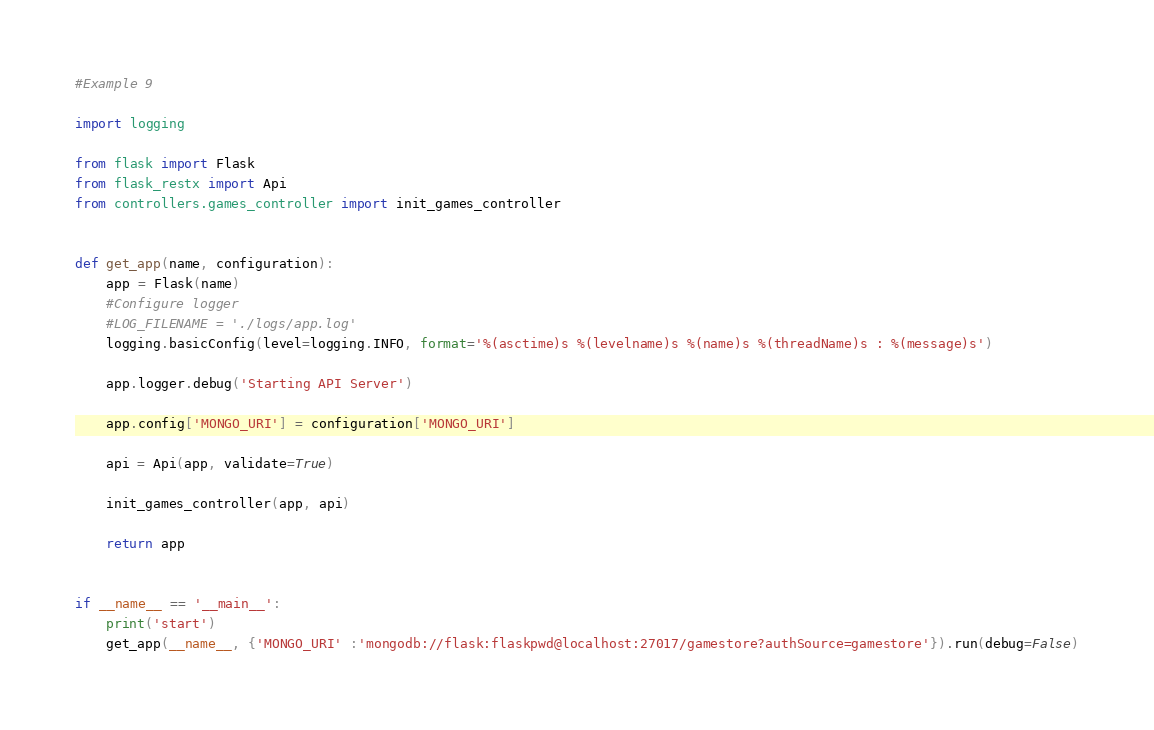<code> <loc_0><loc_0><loc_500><loc_500><_Python_>#Example 9

import logging

from flask import Flask
from flask_restx import Api
from controllers.games_controller import init_games_controller


def get_app(name, configuration):
    app = Flask(name)
    #Configure logger
    #LOG_FILENAME = './logs/app.log'
    logging.basicConfig(level=logging.INFO, format='%(asctime)s %(levelname)s %(name)s %(threadName)s : %(message)s')
    
    app.logger.debug('Starting API Server')

    app.config['MONGO_URI'] = configuration['MONGO_URI']

    api = Api(app, validate=True)

    init_games_controller(app, api)

    return app


if __name__ == '__main__':
    print('start')
    get_app(__name__, {'MONGO_URI' :'mongodb://flask:flaskpwd@localhost:27017/gamestore?authSource=gamestore'}).run(debug=False)
</code> 